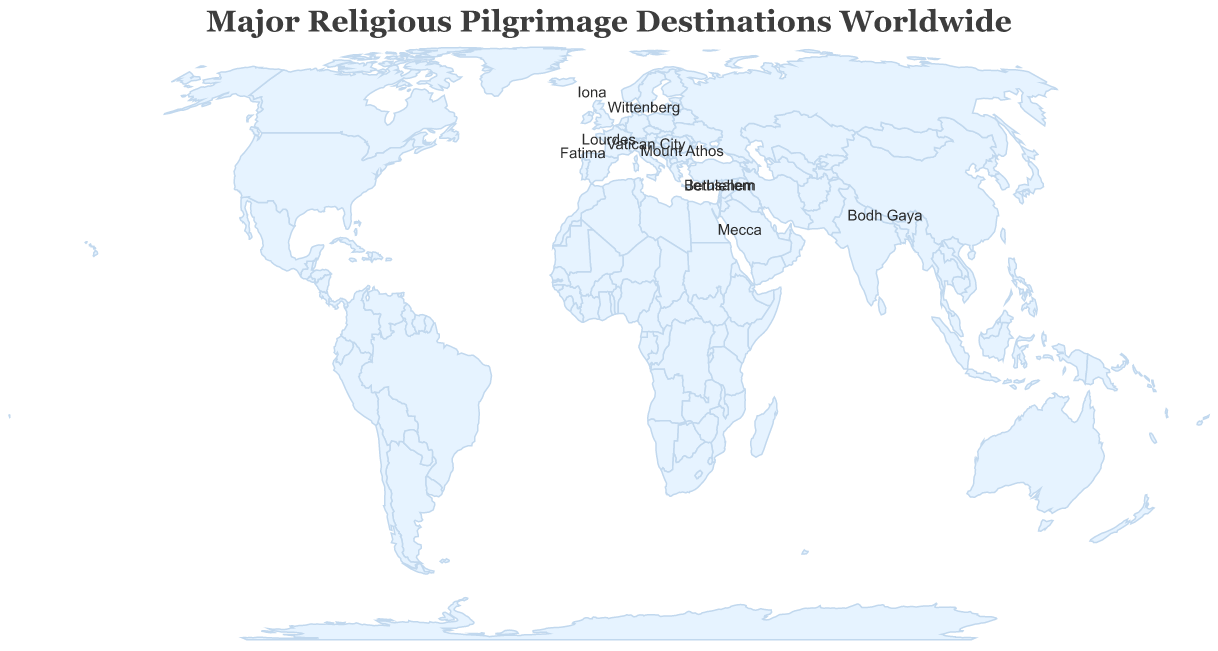Which pilgrimage destination attracts the most annual visitors? By examining the plot, Vatican City and Lourdes both have the largest circle sizes, indicating they have the highest number of annual visitors at 6,000,000 each.
Answer: Vatican City and Lourdes Which destination attracts the fewest annual visitors? The smallest circles on the plot indicate the fewest annual visitors. These correspond to Mount Athos and Iona with 100,000 and 130,000 visitors, respectively.
Answer: Mount Athos How many destinations have over 3,000,000 annual visitors? By observing the size of the circles and referencing the tooltip data, we can identify that Vatican City, Lourdes, Jerusalem, and Fatima have over 3,000,000 annual visitors.
Answer: 4 What is the total number of visitors for Jerusalem and Mecca? Jerusalem attracts 3,500,000 visitors and Mecca 2,000,000 annually. Summing these figures gives 3,500,000 + 2,000,000 = 5,500,000.
Answer: 5,500,000 Which destinations are represented in Asia? By checking the longitude and latitude of the points in Asia, we find that Mecca (Saudi Arabia), Jerusalem (Israel), Bethlehem (Palestine), and Bodh Gaya (India) are the relevant destinations.
Answer: Mecca, Jerusalem, Bethlehem, Bodh Gaya Which destination has the highest religious significance for Christianity but attracts fewer visitors than Fatima? Comparing the religious significance and visitor numbers, Wittenberg is significant for Christianity as the birthplace of the Protestant Reformation and has 200,000 visitors, which is fewer than Fatima's 4,000,000.
Answer: Wittenberg Which destination is both geographically and numerically closer to Vatican City: Lourdes or Jerusalem? Geographically, Lourdes is in France and Jerusalem is in Israel. Numerically, Lourdes has the same visitor number as Vatican City (6,000,000 while Jerusalem has 3,500,000). Lourdes is closer both geographically and numerically.
Answer: Lourdes 